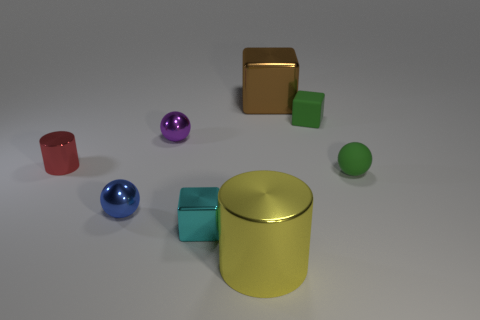Is the color of the tiny rubber cube the same as the large metallic object right of the big yellow metallic object?
Keep it short and to the point. No. There is a large shiny thing that is on the left side of the big object behind the yellow cylinder; what color is it?
Offer a terse response. Yellow. What color is the cylinder that is the same size as the blue sphere?
Provide a succinct answer. Red. Is there a tiny cyan shiny object of the same shape as the purple object?
Your answer should be very brief. No. What shape is the large yellow metal thing?
Keep it short and to the point. Cylinder. Is the number of shiny blocks that are behind the tiny cyan object greater than the number of small metallic blocks behind the brown metal object?
Offer a terse response. Yes. How many other things are the same size as the rubber cube?
Offer a terse response. 5. What material is the small thing that is on the right side of the large brown cube and in front of the tiny rubber block?
Ensure brevity in your answer.  Rubber. There is a yellow thing that is the same shape as the small red metallic thing; what is it made of?
Offer a very short reply. Metal. How many large metallic blocks are on the right side of the large metal thing that is in front of the big object that is behind the tiny blue metallic thing?
Make the answer very short. 1. 